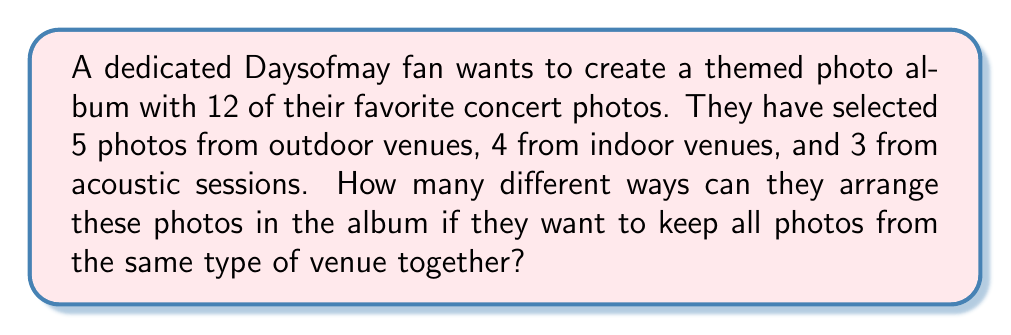Solve this math problem. To solve this problem, we'll break it down into steps using the multiplication principle of counting:

1) First, we need to consider how many ways we can arrange the three groups of photos (outdoor, indoor, acoustic). This is a straightforward permutation of 3 items:

   $3! = 3 \times 2 \times 1 = 6$ ways

2) Next, within each group, we need to consider how many ways the individual photos can be arranged:

   Outdoor photos: 5! ways
   Indoor photos: 4! ways
   Acoustic photos: 3! ways

3) By the multiplication principle, the total number of ways to arrange the photos is:

   $$ 3! \times 5! \times 4! \times 3! $$

4) Let's calculate this:
   $$ 6 \times 120 \times 24 \times 6 = 103,680 $$

Therefore, there are 103,680 different ways to arrange the photos in the album under these conditions.
Answer: 103,680 ways 